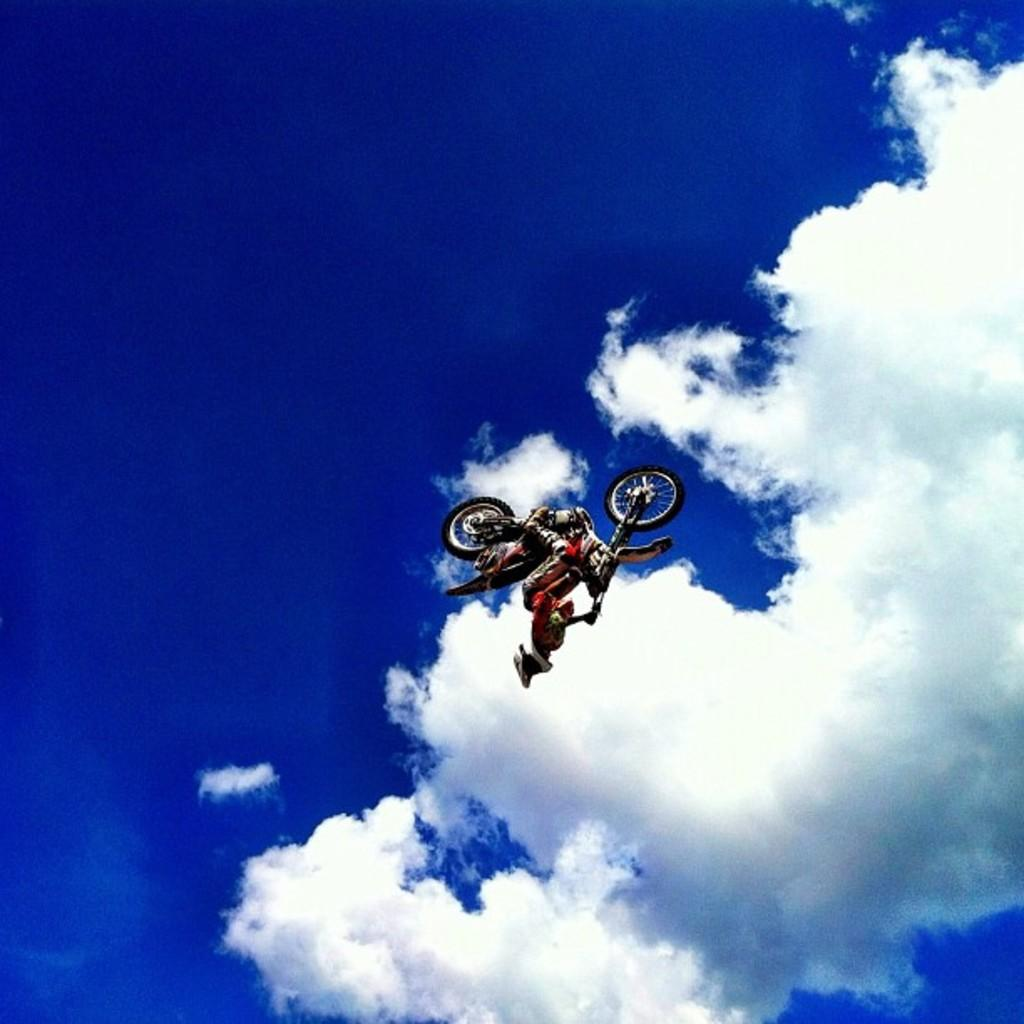What can be seen in the background of the image? The sky is visible in the image. What is the main object in the foreground of the image? There is a bicycle in the image. Is there anyone riding the bicycle? Yes, a person is present on the bicycle. What type of spoon is being used by the person on the bicycle in the image? There is no spoon present in the image; the person is riding a bicycle. 